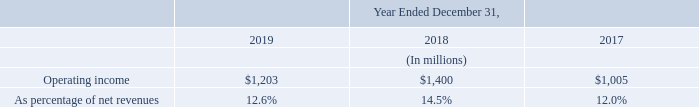Operating income in 2019 was $1,203 million, decreasing by $197 million compared to 2018, reflecting normal price pressure, increased unsaturation charges and higher R&D spending, partially offset by higher level of grants and favorable currency effects, net of hedging.
Operating income in 2018 was $1,400 million, improved by $395 million compared to 2017, reflecting higher volumes, improved manufacturing efficiencies and product mix and lower restructuring charges, partially offset by unfavorable currency effects, net of hedging, normal price pressure and higher operating expenses.
What was the Operating income in 2019? $1,203 million. How much did the operating income decrease in 2019 as compared to 2018? $197 million. What did the improved operating income in 2018 indicate? Reflecting higher volumes, improved manufacturing efficiencies and product mix and lower restructuring charges, partially offset by unfavorable currency effects, net of hedging, normal price pressure and higher operating expenses. What is the average Operating income?
Answer scale should be: million. (1,203+1,400+1,005) / 3
Answer: 1202.67. What is the average operating income as percentage of net revenues?
Answer scale should be: percent. (12.6+14.5+12.0) / 3
Answer: 13.03. What is the increase/ (decrease) in Operating income from 2017 to 2019?
Answer scale should be: million. 1,203-1,005
Answer: 198. 